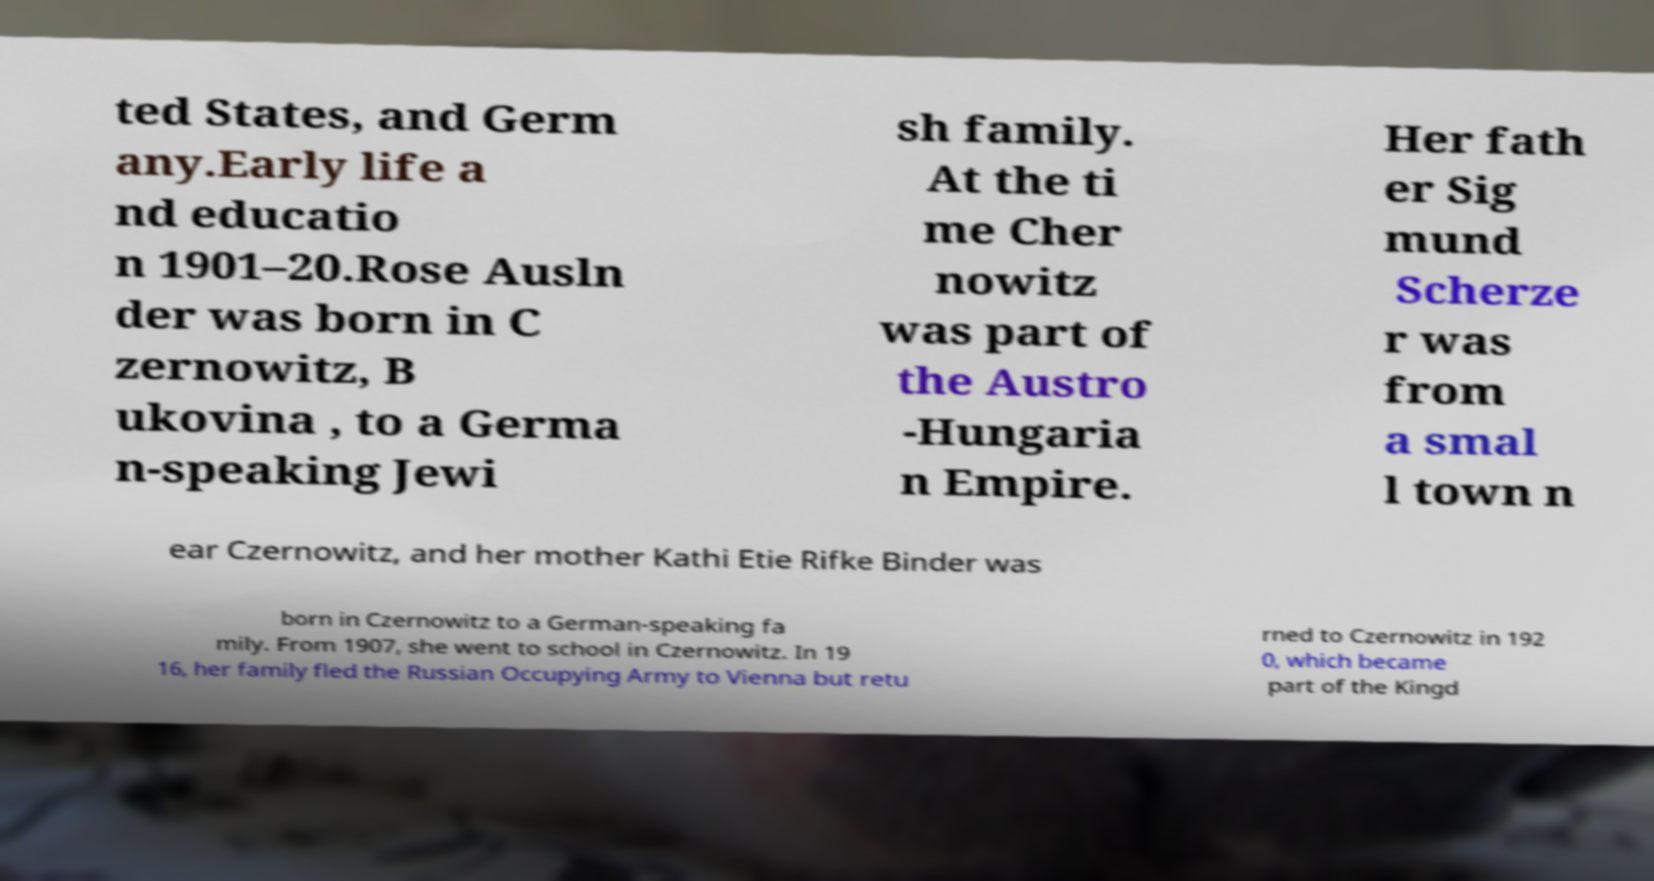For documentation purposes, I need the text within this image transcribed. Could you provide that? ted States, and Germ any.Early life a nd educatio n 1901–20.Rose Ausln der was born in C zernowitz, B ukovina , to a Germa n-speaking Jewi sh family. At the ti me Cher nowitz was part of the Austro -Hungaria n Empire. Her fath er Sig mund Scherze r was from a smal l town n ear Czernowitz, and her mother Kathi Etie Rifke Binder was born in Czernowitz to a German-speaking fa mily. From 1907, she went to school in Czernowitz. In 19 16, her family fled the Russian Occupying Army to Vienna but retu rned to Czernowitz in 192 0, which became part of the Kingd 